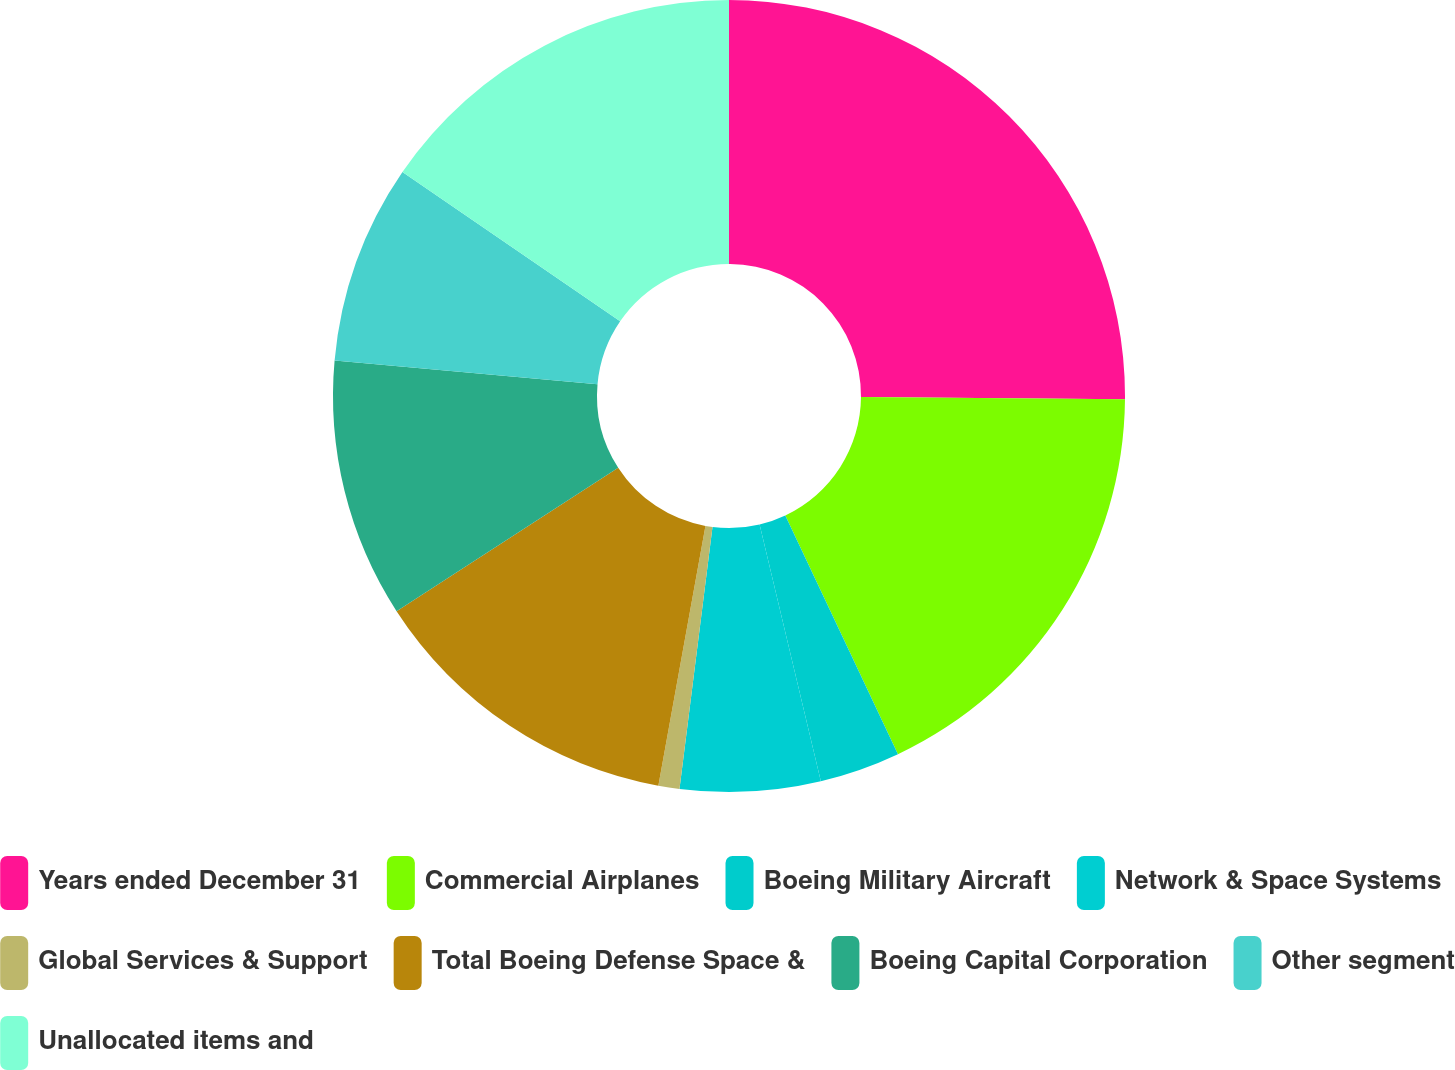Convert chart to OTSL. <chart><loc_0><loc_0><loc_500><loc_500><pie_chart><fcel>Years ended December 31<fcel>Commercial Airplanes<fcel>Boeing Military Aircraft<fcel>Network & Space Systems<fcel>Global Services & Support<fcel>Total Boeing Defense Space &<fcel>Boeing Capital Corporation<fcel>Other segment<fcel>Unallocated items and<nl><fcel>25.13%<fcel>17.85%<fcel>3.29%<fcel>5.72%<fcel>0.86%<fcel>13.0%<fcel>10.57%<fcel>8.14%<fcel>15.43%<nl></chart> 